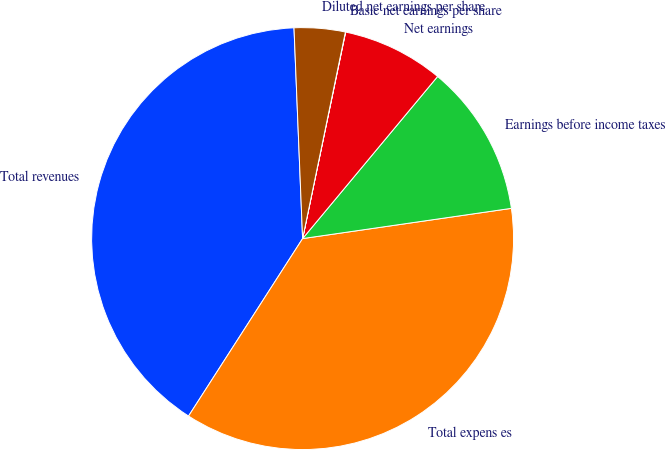Convert chart. <chart><loc_0><loc_0><loc_500><loc_500><pie_chart><fcel>Total revenues<fcel>Total expens es<fcel>Earnings before income taxes<fcel>Net earnings<fcel>Basic net earnings per share<fcel>Diluted net earnings per share<nl><fcel>40.26%<fcel>36.38%<fcel>11.66%<fcel>7.78%<fcel>0.02%<fcel>3.9%<nl></chart> 